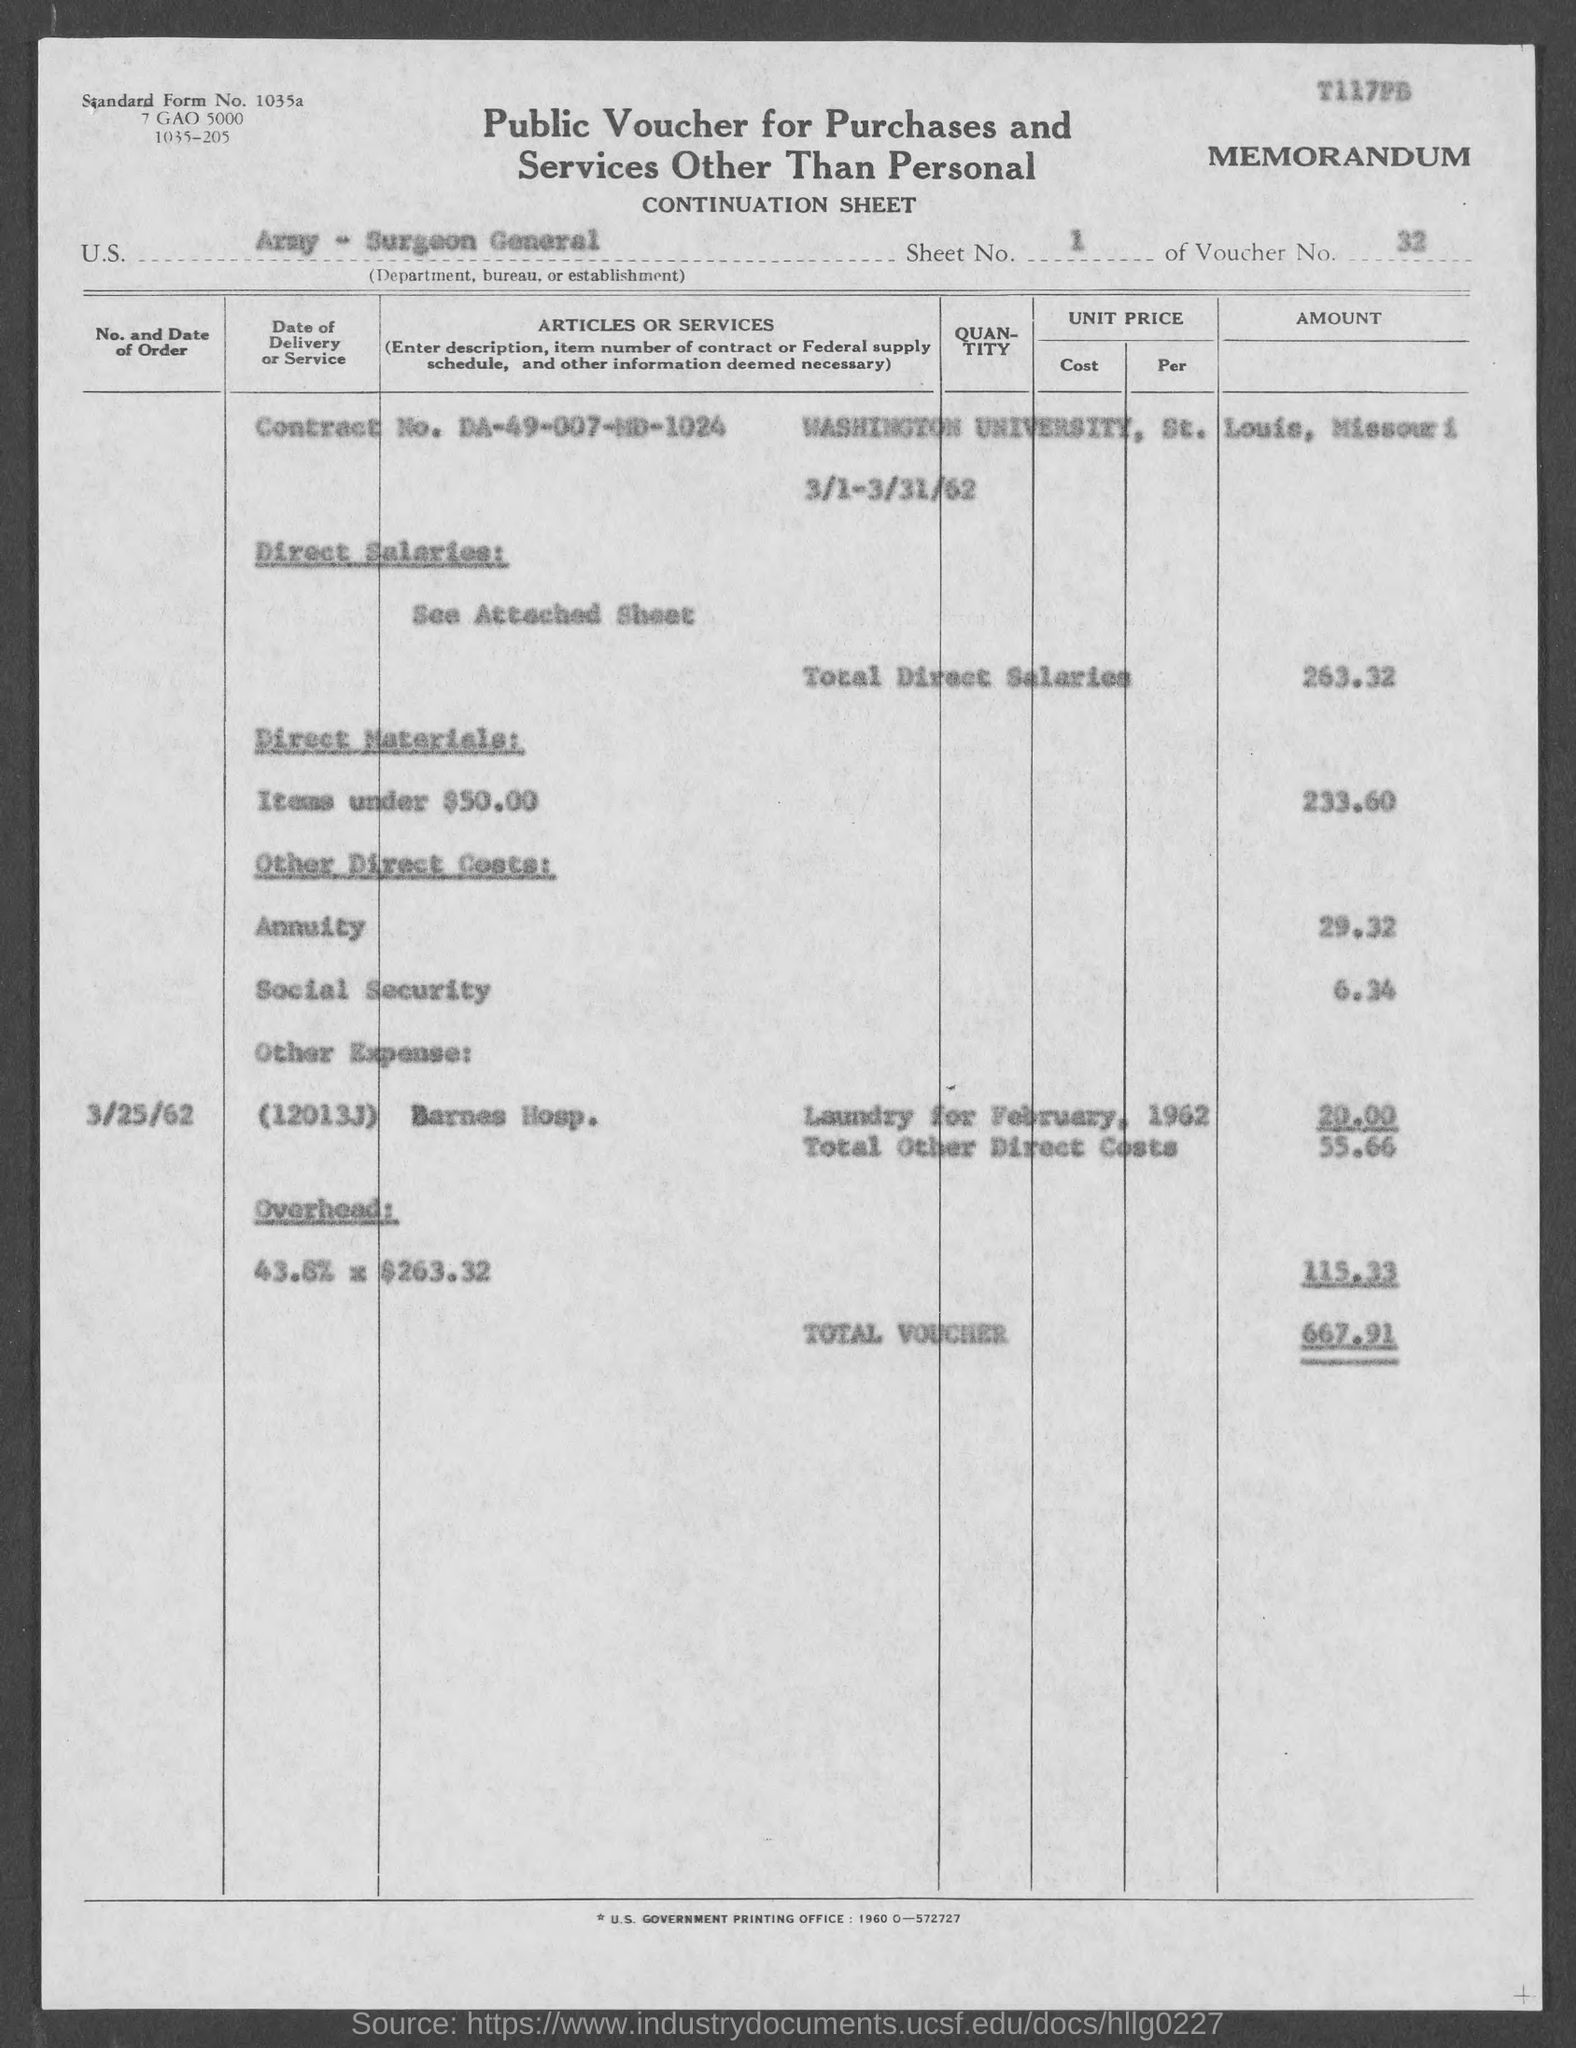what is the cost for Annuity ? The cost for the annuity listed on the voucher appears to be $29.32. Please note that this figure might represent a specific monthly charge during that period or a part of a larger sum depending on additional contract terms not specified here. 